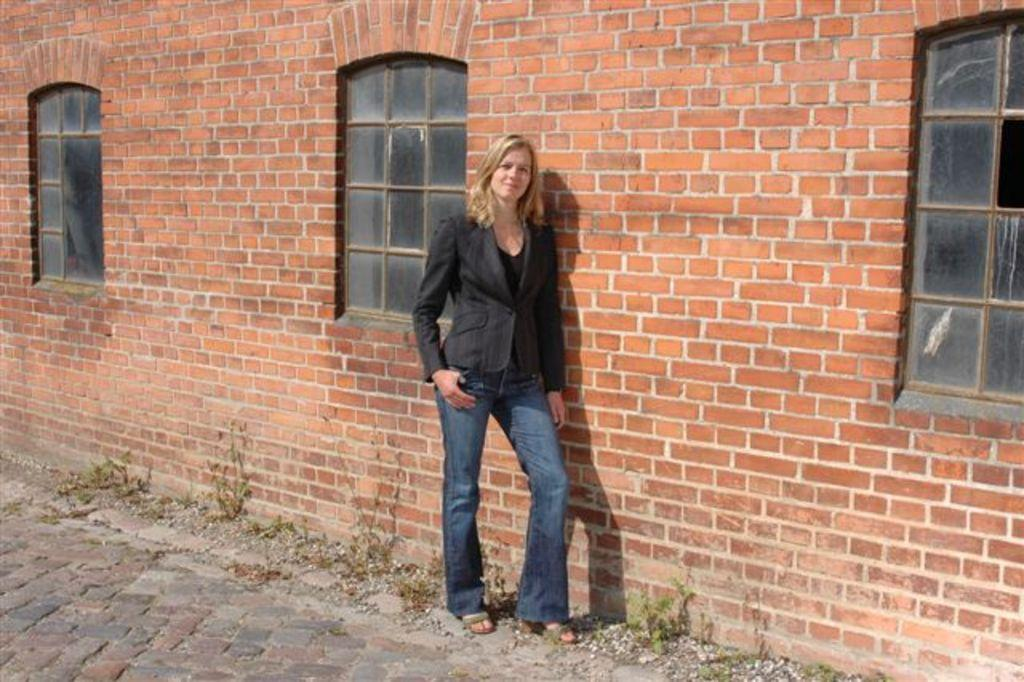What is the main subject in the image? There is a woman standing in the image. Can you describe the background of the image? There is a wall with windows in the background of the image. What type of cars can be seen driving past the woman in the image? There are no cars visible in the image. What type of soda is the woman holding in the image? There is no soda present in the image. What is the woman doing with her tongue in the image? There is no indication of the woman using her tongue in the image. 